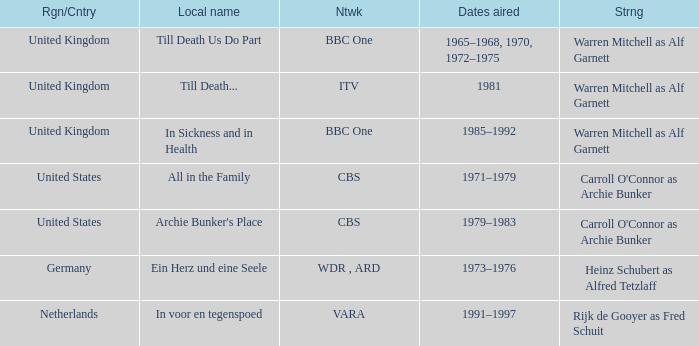What is the local name for the episodes that aired in 1981? Till Death... 